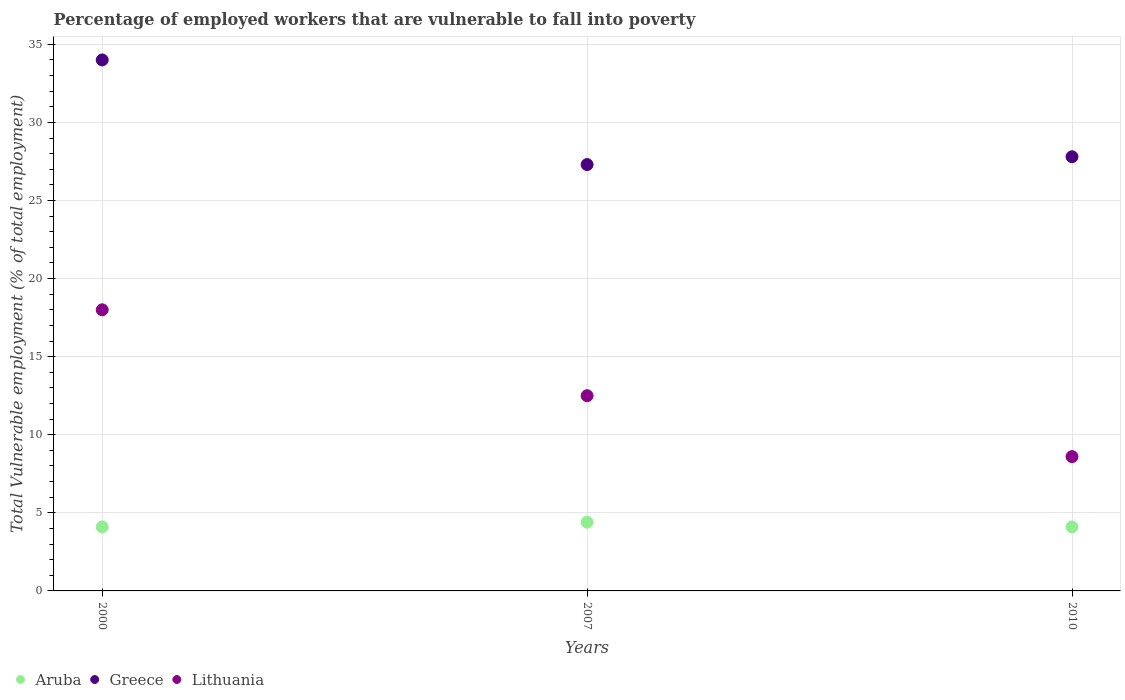How many different coloured dotlines are there?
Provide a succinct answer. 3. Is the number of dotlines equal to the number of legend labels?
Provide a short and direct response. Yes. What is the percentage of employed workers who are vulnerable to fall into poverty in Lithuania in 2007?
Give a very brief answer. 12.5. Across all years, what is the minimum percentage of employed workers who are vulnerable to fall into poverty in Aruba?
Ensure brevity in your answer.  4.1. In which year was the percentage of employed workers who are vulnerable to fall into poverty in Aruba maximum?
Your answer should be compact. 2007. What is the total percentage of employed workers who are vulnerable to fall into poverty in Lithuania in the graph?
Give a very brief answer. 39.1. What is the difference between the percentage of employed workers who are vulnerable to fall into poverty in Lithuania in 2000 and that in 2010?
Offer a terse response. 9.4. What is the difference between the percentage of employed workers who are vulnerable to fall into poverty in Greece in 2000 and the percentage of employed workers who are vulnerable to fall into poverty in Aruba in 2007?
Make the answer very short. 29.6. What is the average percentage of employed workers who are vulnerable to fall into poverty in Lithuania per year?
Make the answer very short. 13.03. In the year 2007, what is the difference between the percentage of employed workers who are vulnerable to fall into poverty in Greece and percentage of employed workers who are vulnerable to fall into poverty in Aruba?
Keep it short and to the point. 22.9. What is the ratio of the percentage of employed workers who are vulnerable to fall into poverty in Greece in 2007 to that in 2010?
Ensure brevity in your answer.  0.98. What is the difference between the highest and the second highest percentage of employed workers who are vulnerable to fall into poverty in Aruba?
Ensure brevity in your answer.  0.3. What is the difference between the highest and the lowest percentage of employed workers who are vulnerable to fall into poverty in Aruba?
Offer a terse response. 0.3. In how many years, is the percentage of employed workers who are vulnerable to fall into poverty in Aruba greater than the average percentage of employed workers who are vulnerable to fall into poverty in Aruba taken over all years?
Your response must be concise. 1. How many years are there in the graph?
Keep it short and to the point. 3. What is the difference between two consecutive major ticks on the Y-axis?
Provide a short and direct response. 5. Does the graph contain any zero values?
Keep it short and to the point. No. How many legend labels are there?
Your response must be concise. 3. What is the title of the graph?
Ensure brevity in your answer.  Percentage of employed workers that are vulnerable to fall into poverty. Does "Philippines" appear as one of the legend labels in the graph?
Keep it short and to the point. No. What is the label or title of the Y-axis?
Offer a terse response. Total Vulnerable employment (% of total employment). What is the Total Vulnerable employment (% of total employment) of Aruba in 2000?
Your response must be concise. 4.1. What is the Total Vulnerable employment (% of total employment) of Greece in 2000?
Provide a succinct answer. 34. What is the Total Vulnerable employment (% of total employment) in Aruba in 2007?
Your answer should be compact. 4.4. What is the Total Vulnerable employment (% of total employment) in Greece in 2007?
Your answer should be compact. 27.3. What is the Total Vulnerable employment (% of total employment) of Lithuania in 2007?
Your answer should be very brief. 12.5. What is the Total Vulnerable employment (% of total employment) of Aruba in 2010?
Offer a very short reply. 4.1. What is the Total Vulnerable employment (% of total employment) of Greece in 2010?
Make the answer very short. 27.8. What is the Total Vulnerable employment (% of total employment) in Lithuania in 2010?
Offer a very short reply. 8.6. Across all years, what is the maximum Total Vulnerable employment (% of total employment) in Aruba?
Your answer should be compact. 4.4. Across all years, what is the minimum Total Vulnerable employment (% of total employment) in Aruba?
Your answer should be very brief. 4.1. Across all years, what is the minimum Total Vulnerable employment (% of total employment) of Greece?
Your answer should be compact. 27.3. Across all years, what is the minimum Total Vulnerable employment (% of total employment) of Lithuania?
Make the answer very short. 8.6. What is the total Total Vulnerable employment (% of total employment) in Aruba in the graph?
Give a very brief answer. 12.6. What is the total Total Vulnerable employment (% of total employment) of Greece in the graph?
Make the answer very short. 89.1. What is the total Total Vulnerable employment (% of total employment) in Lithuania in the graph?
Ensure brevity in your answer.  39.1. What is the difference between the Total Vulnerable employment (% of total employment) of Lithuania in 2000 and that in 2007?
Ensure brevity in your answer.  5.5. What is the difference between the Total Vulnerable employment (% of total employment) in Aruba in 2000 and that in 2010?
Your answer should be compact. 0. What is the difference between the Total Vulnerable employment (% of total employment) of Greece in 2000 and that in 2010?
Offer a terse response. 6.2. What is the difference between the Total Vulnerable employment (% of total employment) of Aruba in 2007 and that in 2010?
Keep it short and to the point. 0.3. What is the difference between the Total Vulnerable employment (% of total employment) of Lithuania in 2007 and that in 2010?
Offer a very short reply. 3.9. What is the difference between the Total Vulnerable employment (% of total employment) in Aruba in 2000 and the Total Vulnerable employment (% of total employment) in Greece in 2007?
Make the answer very short. -23.2. What is the difference between the Total Vulnerable employment (% of total employment) in Aruba in 2000 and the Total Vulnerable employment (% of total employment) in Lithuania in 2007?
Offer a terse response. -8.4. What is the difference between the Total Vulnerable employment (% of total employment) in Aruba in 2000 and the Total Vulnerable employment (% of total employment) in Greece in 2010?
Your answer should be very brief. -23.7. What is the difference between the Total Vulnerable employment (% of total employment) in Aruba in 2000 and the Total Vulnerable employment (% of total employment) in Lithuania in 2010?
Provide a succinct answer. -4.5. What is the difference between the Total Vulnerable employment (% of total employment) of Greece in 2000 and the Total Vulnerable employment (% of total employment) of Lithuania in 2010?
Your response must be concise. 25.4. What is the difference between the Total Vulnerable employment (% of total employment) in Aruba in 2007 and the Total Vulnerable employment (% of total employment) in Greece in 2010?
Offer a terse response. -23.4. What is the average Total Vulnerable employment (% of total employment) in Greece per year?
Provide a succinct answer. 29.7. What is the average Total Vulnerable employment (% of total employment) of Lithuania per year?
Your response must be concise. 13.03. In the year 2000, what is the difference between the Total Vulnerable employment (% of total employment) of Aruba and Total Vulnerable employment (% of total employment) of Greece?
Your answer should be compact. -29.9. In the year 2000, what is the difference between the Total Vulnerable employment (% of total employment) of Aruba and Total Vulnerable employment (% of total employment) of Lithuania?
Give a very brief answer. -13.9. In the year 2007, what is the difference between the Total Vulnerable employment (% of total employment) in Aruba and Total Vulnerable employment (% of total employment) in Greece?
Make the answer very short. -22.9. In the year 2007, what is the difference between the Total Vulnerable employment (% of total employment) in Greece and Total Vulnerable employment (% of total employment) in Lithuania?
Your answer should be very brief. 14.8. In the year 2010, what is the difference between the Total Vulnerable employment (% of total employment) in Aruba and Total Vulnerable employment (% of total employment) in Greece?
Offer a terse response. -23.7. In the year 2010, what is the difference between the Total Vulnerable employment (% of total employment) in Aruba and Total Vulnerable employment (% of total employment) in Lithuania?
Your response must be concise. -4.5. In the year 2010, what is the difference between the Total Vulnerable employment (% of total employment) in Greece and Total Vulnerable employment (% of total employment) in Lithuania?
Offer a terse response. 19.2. What is the ratio of the Total Vulnerable employment (% of total employment) of Aruba in 2000 to that in 2007?
Offer a terse response. 0.93. What is the ratio of the Total Vulnerable employment (% of total employment) of Greece in 2000 to that in 2007?
Offer a very short reply. 1.25. What is the ratio of the Total Vulnerable employment (% of total employment) in Lithuania in 2000 to that in 2007?
Offer a very short reply. 1.44. What is the ratio of the Total Vulnerable employment (% of total employment) of Greece in 2000 to that in 2010?
Offer a terse response. 1.22. What is the ratio of the Total Vulnerable employment (% of total employment) in Lithuania in 2000 to that in 2010?
Offer a very short reply. 2.09. What is the ratio of the Total Vulnerable employment (% of total employment) of Aruba in 2007 to that in 2010?
Keep it short and to the point. 1.07. What is the ratio of the Total Vulnerable employment (% of total employment) of Greece in 2007 to that in 2010?
Offer a very short reply. 0.98. What is the ratio of the Total Vulnerable employment (% of total employment) in Lithuania in 2007 to that in 2010?
Ensure brevity in your answer.  1.45. What is the difference between the highest and the lowest Total Vulnerable employment (% of total employment) in Lithuania?
Your answer should be compact. 9.4. 